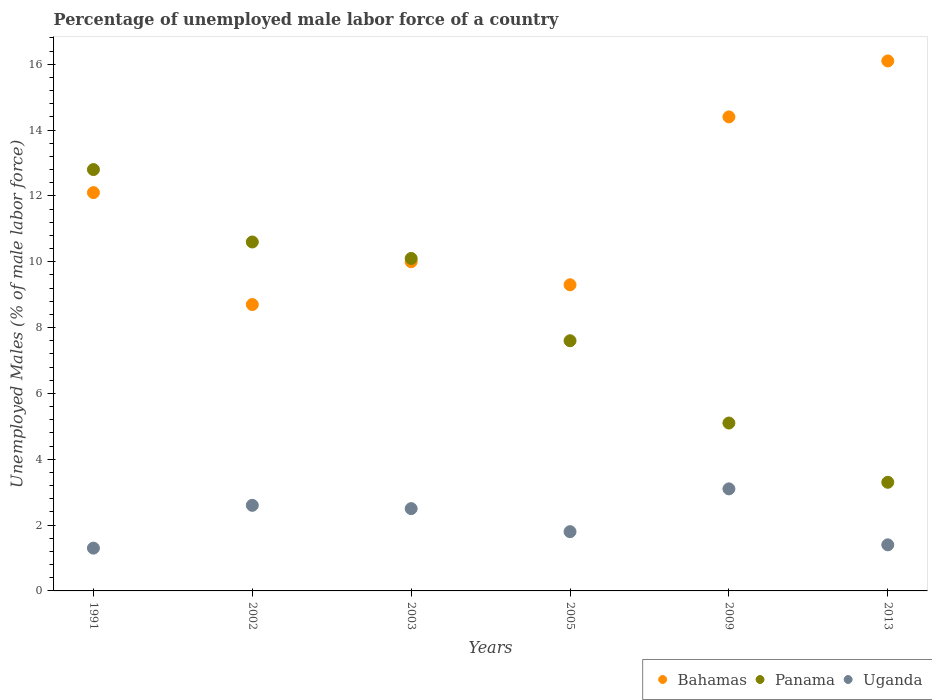Is the number of dotlines equal to the number of legend labels?
Provide a short and direct response. Yes. What is the percentage of unemployed male labor force in Uganda in 1991?
Provide a succinct answer. 1.3. Across all years, what is the maximum percentage of unemployed male labor force in Bahamas?
Make the answer very short. 16.1. Across all years, what is the minimum percentage of unemployed male labor force in Panama?
Make the answer very short. 3.3. What is the total percentage of unemployed male labor force in Bahamas in the graph?
Give a very brief answer. 70.6. What is the difference between the percentage of unemployed male labor force in Uganda in 2002 and that in 2009?
Your response must be concise. -0.5. What is the difference between the percentage of unemployed male labor force in Uganda in 2002 and the percentage of unemployed male labor force in Panama in 2005?
Provide a succinct answer. -5. What is the average percentage of unemployed male labor force in Panama per year?
Your answer should be very brief. 8.25. In the year 2013, what is the difference between the percentage of unemployed male labor force in Bahamas and percentage of unemployed male labor force in Panama?
Your answer should be very brief. 12.8. What is the ratio of the percentage of unemployed male labor force in Panama in 1991 to that in 2005?
Provide a short and direct response. 1.68. Is the percentage of unemployed male labor force in Uganda in 2002 less than that in 2005?
Keep it short and to the point. No. What is the difference between the highest and the lowest percentage of unemployed male labor force in Uganda?
Offer a very short reply. 1.8. In how many years, is the percentage of unemployed male labor force in Panama greater than the average percentage of unemployed male labor force in Panama taken over all years?
Your answer should be very brief. 3. Is the sum of the percentage of unemployed male labor force in Panama in 2002 and 2009 greater than the maximum percentage of unemployed male labor force in Bahamas across all years?
Your response must be concise. No. Is it the case that in every year, the sum of the percentage of unemployed male labor force in Panama and percentage of unemployed male labor force in Uganda  is greater than the percentage of unemployed male labor force in Bahamas?
Your answer should be very brief. No. Does the percentage of unemployed male labor force in Bahamas monotonically increase over the years?
Your answer should be compact. No. Is the percentage of unemployed male labor force in Panama strictly greater than the percentage of unemployed male labor force in Bahamas over the years?
Offer a terse response. No. How many years are there in the graph?
Ensure brevity in your answer.  6. What is the difference between two consecutive major ticks on the Y-axis?
Give a very brief answer. 2. Are the values on the major ticks of Y-axis written in scientific E-notation?
Your answer should be compact. No. How are the legend labels stacked?
Make the answer very short. Horizontal. What is the title of the graph?
Offer a very short reply. Percentage of unemployed male labor force of a country. Does "Zimbabwe" appear as one of the legend labels in the graph?
Make the answer very short. No. What is the label or title of the X-axis?
Keep it short and to the point. Years. What is the label or title of the Y-axis?
Keep it short and to the point. Unemployed Males (% of male labor force). What is the Unemployed Males (% of male labor force) in Bahamas in 1991?
Provide a succinct answer. 12.1. What is the Unemployed Males (% of male labor force) of Panama in 1991?
Offer a very short reply. 12.8. What is the Unemployed Males (% of male labor force) of Uganda in 1991?
Make the answer very short. 1.3. What is the Unemployed Males (% of male labor force) of Bahamas in 2002?
Your answer should be very brief. 8.7. What is the Unemployed Males (% of male labor force) in Panama in 2002?
Keep it short and to the point. 10.6. What is the Unemployed Males (% of male labor force) in Uganda in 2002?
Make the answer very short. 2.6. What is the Unemployed Males (% of male labor force) in Panama in 2003?
Your response must be concise. 10.1. What is the Unemployed Males (% of male labor force) of Bahamas in 2005?
Offer a terse response. 9.3. What is the Unemployed Males (% of male labor force) in Panama in 2005?
Keep it short and to the point. 7.6. What is the Unemployed Males (% of male labor force) of Uganda in 2005?
Make the answer very short. 1.8. What is the Unemployed Males (% of male labor force) of Bahamas in 2009?
Make the answer very short. 14.4. What is the Unemployed Males (% of male labor force) in Panama in 2009?
Provide a short and direct response. 5.1. What is the Unemployed Males (% of male labor force) in Uganda in 2009?
Make the answer very short. 3.1. What is the Unemployed Males (% of male labor force) of Bahamas in 2013?
Provide a short and direct response. 16.1. What is the Unemployed Males (% of male labor force) of Panama in 2013?
Your answer should be compact. 3.3. What is the Unemployed Males (% of male labor force) in Uganda in 2013?
Provide a succinct answer. 1.4. Across all years, what is the maximum Unemployed Males (% of male labor force) in Bahamas?
Make the answer very short. 16.1. Across all years, what is the maximum Unemployed Males (% of male labor force) of Panama?
Offer a terse response. 12.8. Across all years, what is the maximum Unemployed Males (% of male labor force) in Uganda?
Your answer should be compact. 3.1. Across all years, what is the minimum Unemployed Males (% of male labor force) of Bahamas?
Keep it short and to the point. 8.7. Across all years, what is the minimum Unemployed Males (% of male labor force) of Panama?
Offer a very short reply. 3.3. Across all years, what is the minimum Unemployed Males (% of male labor force) in Uganda?
Offer a terse response. 1.3. What is the total Unemployed Males (% of male labor force) in Bahamas in the graph?
Make the answer very short. 70.6. What is the total Unemployed Males (% of male labor force) of Panama in the graph?
Your answer should be compact. 49.5. What is the difference between the Unemployed Males (% of male labor force) in Bahamas in 1991 and that in 2002?
Make the answer very short. 3.4. What is the difference between the Unemployed Males (% of male labor force) of Panama in 1991 and that in 2003?
Your response must be concise. 2.7. What is the difference between the Unemployed Males (% of male labor force) in Bahamas in 1991 and that in 2005?
Offer a very short reply. 2.8. What is the difference between the Unemployed Males (% of male labor force) of Panama in 1991 and that in 2009?
Your answer should be compact. 7.7. What is the difference between the Unemployed Males (% of male labor force) of Uganda in 1991 and that in 2009?
Provide a succinct answer. -1.8. What is the difference between the Unemployed Males (% of male labor force) in Bahamas in 1991 and that in 2013?
Your response must be concise. -4. What is the difference between the Unemployed Males (% of male labor force) in Panama in 1991 and that in 2013?
Keep it short and to the point. 9.5. What is the difference between the Unemployed Males (% of male labor force) of Bahamas in 2002 and that in 2003?
Your answer should be compact. -1.3. What is the difference between the Unemployed Males (% of male labor force) of Panama in 2002 and that in 2005?
Offer a terse response. 3. What is the difference between the Unemployed Males (% of male labor force) of Uganda in 2002 and that in 2005?
Ensure brevity in your answer.  0.8. What is the difference between the Unemployed Males (% of male labor force) in Bahamas in 2002 and that in 2009?
Your answer should be very brief. -5.7. What is the difference between the Unemployed Males (% of male labor force) in Panama in 2002 and that in 2009?
Keep it short and to the point. 5.5. What is the difference between the Unemployed Males (% of male labor force) of Panama in 2002 and that in 2013?
Give a very brief answer. 7.3. What is the difference between the Unemployed Males (% of male labor force) of Bahamas in 2003 and that in 2005?
Provide a succinct answer. 0.7. What is the difference between the Unemployed Males (% of male labor force) in Uganda in 2003 and that in 2005?
Ensure brevity in your answer.  0.7. What is the difference between the Unemployed Males (% of male labor force) in Bahamas in 2003 and that in 2009?
Your response must be concise. -4.4. What is the difference between the Unemployed Males (% of male labor force) of Panama in 2003 and that in 2009?
Your answer should be very brief. 5. What is the difference between the Unemployed Males (% of male labor force) of Bahamas in 2003 and that in 2013?
Your response must be concise. -6.1. What is the difference between the Unemployed Males (% of male labor force) of Panama in 2003 and that in 2013?
Make the answer very short. 6.8. What is the difference between the Unemployed Males (% of male labor force) in Uganda in 2003 and that in 2013?
Provide a succinct answer. 1.1. What is the difference between the Unemployed Males (% of male labor force) of Uganda in 2005 and that in 2009?
Give a very brief answer. -1.3. What is the difference between the Unemployed Males (% of male labor force) in Bahamas in 2005 and that in 2013?
Make the answer very short. -6.8. What is the difference between the Unemployed Males (% of male labor force) in Panama in 2005 and that in 2013?
Offer a very short reply. 4.3. What is the difference between the Unemployed Males (% of male labor force) in Uganda in 2005 and that in 2013?
Provide a succinct answer. 0.4. What is the difference between the Unemployed Males (% of male labor force) of Bahamas in 2009 and that in 2013?
Provide a short and direct response. -1.7. What is the difference between the Unemployed Males (% of male labor force) in Uganda in 2009 and that in 2013?
Keep it short and to the point. 1.7. What is the difference between the Unemployed Males (% of male labor force) of Panama in 1991 and the Unemployed Males (% of male labor force) of Uganda in 2002?
Keep it short and to the point. 10.2. What is the difference between the Unemployed Males (% of male labor force) of Bahamas in 1991 and the Unemployed Males (% of male labor force) of Panama in 2003?
Make the answer very short. 2. What is the difference between the Unemployed Males (% of male labor force) of Panama in 1991 and the Unemployed Males (% of male labor force) of Uganda in 2003?
Provide a succinct answer. 10.3. What is the difference between the Unemployed Males (% of male labor force) in Panama in 1991 and the Unemployed Males (% of male labor force) in Uganda in 2005?
Provide a short and direct response. 11. What is the difference between the Unemployed Males (% of male labor force) in Panama in 1991 and the Unemployed Males (% of male labor force) in Uganda in 2009?
Your answer should be compact. 9.7. What is the difference between the Unemployed Males (% of male labor force) in Bahamas in 1991 and the Unemployed Males (% of male labor force) in Panama in 2013?
Offer a terse response. 8.8. What is the difference between the Unemployed Males (% of male labor force) in Panama in 1991 and the Unemployed Males (% of male labor force) in Uganda in 2013?
Give a very brief answer. 11.4. What is the difference between the Unemployed Males (% of male labor force) in Bahamas in 2002 and the Unemployed Males (% of male labor force) in Panama in 2003?
Your answer should be very brief. -1.4. What is the difference between the Unemployed Males (% of male labor force) of Panama in 2002 and the Unemployed Males (% of male labor force) of Uganda in 2003?
Provide a short and direct response. 8.1. What is the difference between the Unemployed Males (% of male labor force) in Bahamas in 2002 and the Unemployed Males (% of male labor force) in Uganda in 2005?
Keep it short and to the point. 6.9. What is the difference between the Unemployed Males (% of male labor force) of Panama in 2002 and the Unemployed Males (% of male labor force) of Uganda in 2005?
Your answer should be very brief. 8.8. What is the difference between the Unemployed Males (% of male labor force) of Bahamas in 2002 and the Unemployed Males (% of male labor force) of Panama in 2013?
Your answer should be very brief. 5.4. What is the difference between the Unemployed Males (% of male labor force) of Bahamas in 2002 and the Unemployed Males (% of male labor force) of Uganda in 2013?
Your answer should be compact. 7.3. What is the difference between the Unemployed Males (% of male labor force) in Bahamas in 2003 and the Unemployed Males (% of male labor force) in Panama in 2005?
Your response must be concise. 2.4. What is the difference between the Unemployed Males (% of male labor force) in Bahamas in 2003 and the Unemployed Males (% of male labor force) in Uganda in 2005?
Your answer should be very brief. 8.2. What is the difference between the Unemployed Males (% of male labor force) of Panama in 2003 and the Unemployed Males (% of male labor force) of Uganda in 2005?
Your answer should be compact. 8.3. What is the difference between the Unemployed Males (% of male labor force) in Bahamas in 2003 and the Unemployed Males (% of male labor force) in Uganda in 2009?
Offer a terse response. 6.9. What is the difference between the Unemployed Males (% of male labor force) of Panama in 2003 and the Unemployed Males (% of male labor force) of Uganda in 2009?
Your answer should be compact. 7. What is the difference between the Unemployed Males (% of male labor force) of Bahamas in 2003 and the Unemployed Males (% of male labor force) of Panama in 2013?
Offer a very short reply. 6.7. What is the difference between the Unemployed Males (% of male labor force) in Bahamas in 2003 and the Unemployed Males (% of male labor force) in Uganda in 2013?
Offer a very short reply. 8.6. What is the difference between the Unemployed Males (% of male labor force) of Bahamas in 2005 and the Unemployed Males (% of male labor force) of Panama in 2013?
Your answer should be very brief. 6. What is the difference between the Unemployed Males (% of male labor force) in Bahamas in 2005 and the Unemployed Males (% of male labor force) in Uganda in 2013?
Make the answer very short. 7.9. What is the difference between the Unemployed Males (% of male labor force) of Panama in 2005 and the Unemployed Males (% of male labor force) of Uganda in 2013?
Your answer should be very brief. 6.2. What is the difference between the Unemployed Males (% of male labor force) in Bahamas in 2009 and the Unemployed Males (% of male labor force) in Uganda in 2013?
Your answer should be compact. 13. What is the average Unemployed Males (% of male labor force) of Bahamas per year?
Provide a succinct answer. 11.77. What is the average Unemployed Males (% of male labor force) of Panama per year?
Keep it short and to the point. 8.25. What is the average Unemployed Males (% of male labor force) in Uganda per year?
Make the answer very short. 2.12. In the year 1991, what is the difference between the Unemployed Males (% of male labor force) of Bahamas and Unemployed Males (% of male labor force) of Panama?
Your answer should be compact. -0.7. In the year 1991, what is the difference between the Unemployed Males (% of male labor force) of Panama and Unemployed Males (% of male labor force) of Uganda?
Make the answer very short. 11.5. In the year 2002, what is the difference between the Unemployed Males (% of male labor force) of Bahamas and Unemployed Males (% of male labor force) of Panama?
Offer a very short reply. -1.9. In the year 2002, what is the difference between the Unemployed Males (% of male labor force) in Bahamas and Unemployed Males (% of male labor force) in Uganda?
Keep it short and to the point. 6.1. In the year 2002, what is the difference between the Unemployed Males (% of male labor force) in Panama and Unemployed Males (% of male labor force) in Uganda?
Keep it short and to the point. 8. In the year 2003, what is the difference between the Unemployed Males (% of male labor force) of Bahamas and Unemployed Males (% of male labor force) of Panama?
Your answer should be compact. -0.1. In the year 2003, what is the difference between the Unemployed Males (% of male labor force) in Bahamas and Unemployed Males (% of male labor force) in Uganda?
Provide a short and direct response. 7.5. In the year 2003, what is the difference between the Unemployed Males (% of male labor force) in Panama and Unemployed Males (% of male labor force) in Uganda?
Provide a succinct answer. 7.6. In the year 2005, what is the difference between the Unemployed Males (% of male labor force) of Bahamas and Unemployed Males (% of male labor force) of Uganda?
Offer a very short reply. 7.5. In the year 2009, what is the difference between the Unemployed Males (% of male labor force) of Bahamas and Unemployed Males (% of male labor force) of Panama?
Offer a very short reply. 9.3. In the year 2009, what is the difference between the Unemployed Males (% of male labor force) in Panama and Unemployed Males (% of male labor force) in Uganda?
Provide a succinct answer. 2. In the year 2013, what is the difference between the Unemployed Males (% of male labor force) in Bahamas and Unemployed Males (% of male labor force) in Panama?
Your response must be concise. 12.8. What is the ratio of the Unemployed Males (% of male labor force) of Bahamas in 1991 to that in 2002?
Provide a succinct answer. 1.39. What is the ratio of the Unemployed Males (% of male labor force) in Panama in 1991 to that in 2002?
Offer a very short reply. 1.21. What is the ratio of the Unemployed Males (% of male labor force) in Bahamas in 1991 to that in 2003?
Your answer should be compact. 1.21. What is the ratio of the Unemployed Males (% of male labor force) in Panama in 1991 to that in 2003?
Give a very brief answer. 1.27. What is the ratio of the Unemployed Males (% of male labor force) of Uganda in 1991 to that in 2003?
Your answer should be compact. 0.52. What is the ratio of the Unemployed Males (% of male labor force) in Bahamas in 1991 to that in 2005?
Ensure brevity in your answer.  1.3. What is the ratio of the Unemployed Males (% of male labor force) in Panama in 1991 to that in 2005?
Your response must be concise. 1.68. What is the ratio of the Unemployed Males (% of male labor force) in Uganda in 1991 to that in 2005?
Ensure brevity in your answer.  0.72. What is the ratio of the Unemployed Males (% of male labor force) of Bahamas in 1991 to that in 2009?
Offer a very short reply. 0.84. What is the ratio of the Unemployed Males (% of male labor force) in Panama in 1991 to that in 2009?
Offer a terse response. 2.51. What is the ratio of the Unemployed Males (% of male labor force) of Uganda in 1991 to that in 2009?
Make the answer very short. 0.42. What is the ratio of the Unemployed Males (% of male labor force) in Bahamas in 1991 to that in 2013?
Keep it short and to the point. 0.75. What is the ratio of the Unemployed Males (% of male labor force) of Panama in 1991 to that in 2013?
Ensure brevity in your answer.  3.88. What is the ratio of the Unemployed Males (% of male labor force) of Uganda in 1991 to that in 2013?
Keep it short and to the point. 0.93. What is the ratio of the Unemployed Males (% of male labor force) of Bahamas in 2002 to that in 2003?
Keep it short and to the point. 0.87. What is the ratio of the Unemployed Males (% of male labor force) of Panama in 2002 to that in 2003?
Give a very brief answer. 1.05. What is the ratio of the Unemployed Males (% of male labor force) in Uganda in 2002 to that in 2003?
Offer a very short reply. 1.04. What is the ratio of the Unemployed Males (% of male labor force) of Bahamas in 2002 to that in 2005?
Make the answer very short. 0.94. What is the ratio of the Unemployed Males (% of male labor force) of Panama in 2002 to that in 2005?
Offer a terse response. 1.39. What is the ratio of the Unemployed Males (% of male labor force) in Uganda in 2002 to that in 2005?
Provide a succinct answer. 1.44. What is the ratio of the Unemployed Males (% of male labor force) of Bahamas in 2002 to that in 2009?
Make the answer very short. 0.6. What is the ratio of the Unemployed Males (% of male labor force) in Panama in 2002 to that in 2009?
Offer a terse response. 2.08. What is the ratio of the Unemployed Males (% of male labor force) of Uganda in 2002 to that in 2009?
Offer a very short reply. 0.84. What is the ratio of the Unemployed Males (% of male labor force) in Bahamas in 2002 to that in 2013?
Provide a short and direct response. 0.54. What is the ratio of the Unemployed Males (% of male labor force) in Panama in 2002 to that in 2013?
Offer a terse response. 3.21. What is the ratio of the Unemployed Males (% of male labor force) in Uganda in 2002 to that in 2013?
Your answer should be compact. 1.86. What is the ratio of the Unemployed Males (% of male labor force) in Bahamas in 2003 to that in 2005?
Provide a short and direct response. 1.08. What is the ratio of the Unemployed Males (% of male labor force) of Panama in 2003 to that in 2005?
Keep it short and to the point. 1.33. What is the ratio of the Unemployed Males (% of male labor force) of Uganda in 2003 to that in 2005?
Your answer should be very brief. 1.39. What is the ratio of the Unemployed Males (% of male labor force) of Bahamas in 2003 to that in 2009?
Give a very brief answer. 0.69. What is the ratio of the Unemployed Males (% of male labor force) in Panama in 2003 to that in 2009?
Your answer should be compact. 1.98. What is the ratio of the Unemployed Males (% of male labor force) of Uganda in 2003 to that in 2009?
Keep it short and to the point. 0.81. What is the ratio of the Unemployed Males (% of male labor force) of Bahamas in 2003 to that in 2013?
Give a very brief answer. 0.62. What is the ratio of the Unemployed Males (% of male labor force) in Panama in 2003 to that in 2013?
Offer a terse response. 3.06. What is the ratio of the Unemployed Males (% of male labor force) in Uganda in 2003 to that in 2013?
Your answer should be very brief. 1.79. What is the ratio of the Unemployed Males (% of male labor force) of Bahamas in 2005 to that in 2009?
Your answer should be very brief. 0.65. What is the ratio of the Unemployed Males (% of male labor force) in Panama in 2005 to that in 2009?
Ensure brevity in your answer.  1.49. What is the ratio of the Unemployed Males (% of male labor force) in Uganda in 2005 to that in 2009?
Your answer should be compact. 0.58. What is the ratio of the Unemployed Males (% of male labor force) of Bahamas in 2005 to that in 2013?
Provide a short and direct response. 0.58. What is the ratio of the Unemployed Males (% of male labor force) of Panama in 2005 to that in 2013?
Give a very brief answer. 2.3. What is the ratio of the Unemployed Males (% of male labor force) of Uganda in 2005 to that in 2013?
Offer a very short reply. 1.29. What is the ratio of the Unemployed Males (% of male labor force) in Bahamas in 2009 to that in 2013?
Ensure brevity in your answer.  0.89. What is the ratio of the Unemployed Males (% of male labor force) of Panama in 2009 to that in 2013?
Your response must be concise. 1.55. What is the ratio of the Unemployed Males (% of male labor force) in Uganda in 2009 to that in 2013?
Ensure brevity in your answer.  2.21. What is the difference between the highest and the second highest Unemployed Males (% of male labor force) of Bahamas?
Ensure brevity in your answer.  1.7. What is the difference between the highest and the second highest Unemployed Males (% of male labor force) in Panama?
Keep it short and to the point. 2.2. What is the difference between the highest and the lowest Unemployed Males (% of male labor force) in Bahamas?
Keep it short and to the point. 7.4. What is the difference between the highest and the lowest Unemployed Males (% of male labor force) of Panama?
Keep it short and to the point. 9.5. What is the difference between the highest and the lowest Unemployed Males (% of male labor force) of Uganda?
Provide a succinct answer. 1.8. 